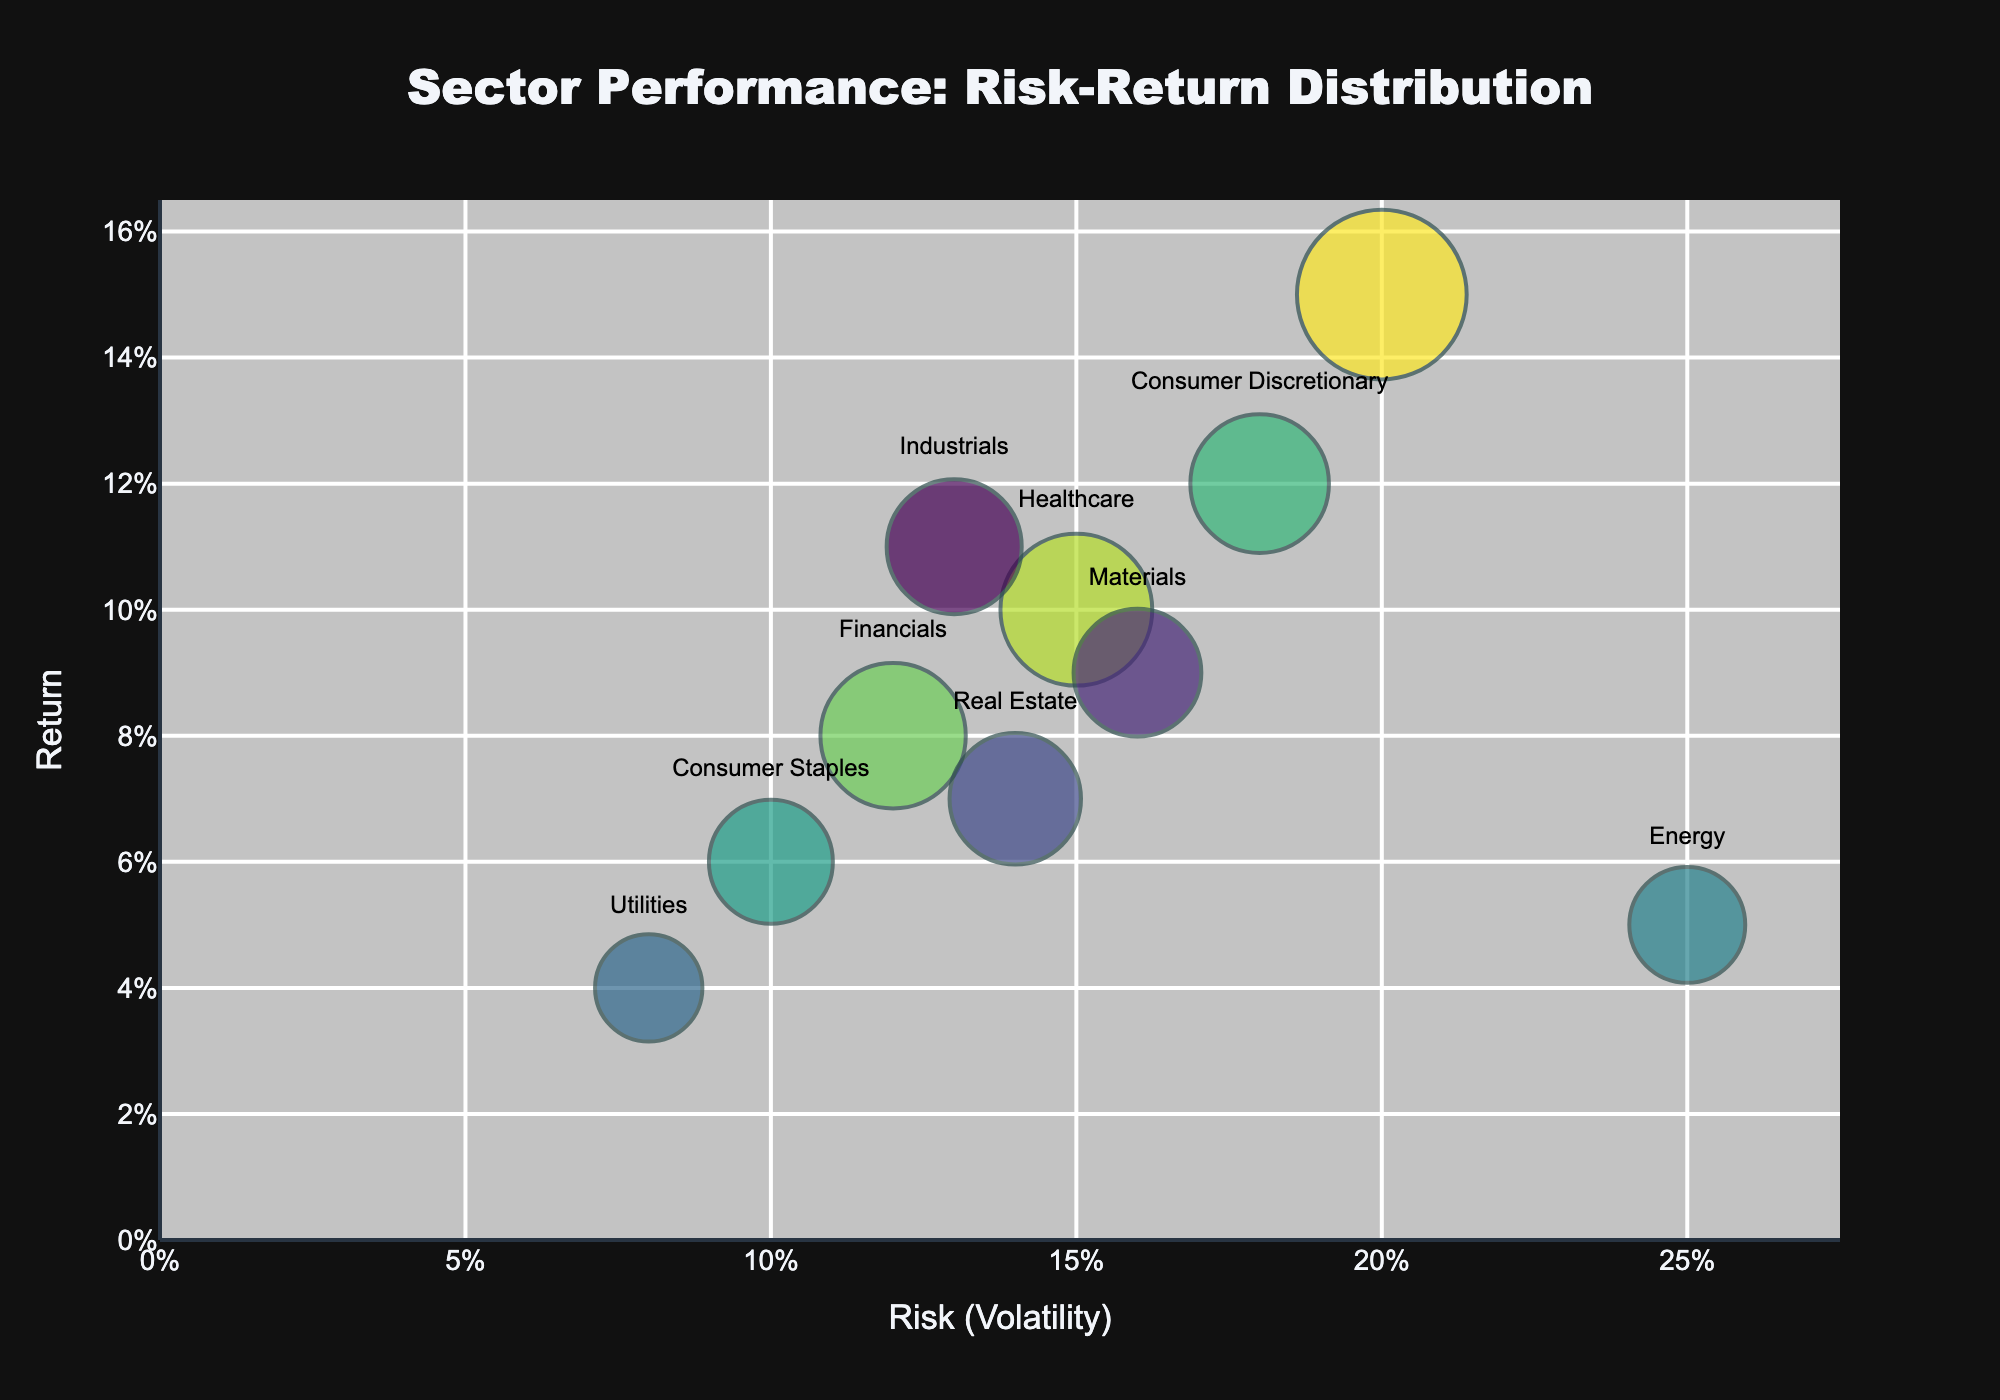What's the title of the chart? The title is at the top center of the chart, and it reads "Sector Performance: Risk-Return Distribution".
Answer: Sector Performance: Risk-Return Distribution What does the x-axis represent? The label for the x-axis shows "Risk (Volatility)," indicating it measures the volatility of each sector's performance.
Answer: Risk (Volatility) What does the y-axis represent? The label for the y-axis shows "Return," indicating it measures the return of each sector's performance.
Answer: Return Which sector has the highest return? Look for the bubble with the highest position on the y-axis. The "Technology" sector is at the topmost position.
Answer: Technology Which sector has the largest market capitalization? The size of the bubbles represents the market cap. The largest bubble is for the "Technology" sector.
Answer: Technology How does the volatility of the "Energy" sector compare to the "Utilities" sector? Locate both bubbles on the x-axis. The "Energy" sector is higher on the x-axis compared to the "Utilities" sector, indicating that Energy has higher volatility.
Answer: More volatile Which sectors have a return higher than 0.10? Identify bubbles positioned above the 0.10 mark on the y-axis. The sectors are "Technology," "Consumer Discretionary," and "Industrials".
Answer: Technology, Consumer Discretionary, Industrials Which sector has the lowest risk (volatility)? Find the bubble closest to the origin on the x-axis. The "Utilities" sector has the lowest volatility.
Answer: Utilities What is the risk-return profile of the "Healthcare" sector? The "Healthcare" sector's bubble is located at 0.15 on the x-axis (volatility) and 0.10 on the y-axis (return).
Answer: Volatility: 0.15, Return: 0.10 How many sectors are displayed in the chart? Count the number of bubbles in the chart. There are 10 bubbles, representing 10 sectors.
Answer: 10 